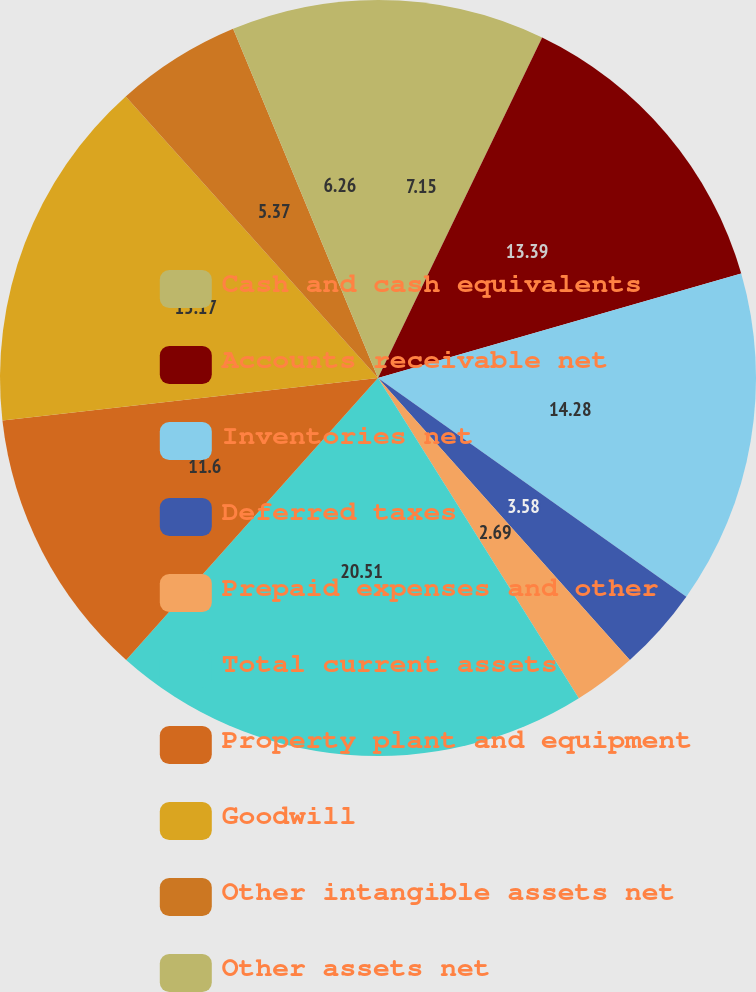<chart> <loc_0><loc_0><loc_500><loc_500><pie_chart><fcel>Cash and cash equivalents<fcel>Accounts receivable net<fcel>Inventories net<fcel>Deferred taxes<fcel>Prepaid expenses and other<fcel>Total current assets<fcel>Property plant and equipment<fcel>Goodwill<fcel>Other intangible assets net<fcel>Other assets net<nl><fcel>7.15%<fcel>13.39%<fcel>14.28%<fcel>3.58%<fcel>2.69%<fcel>20.52%<fcel>11.6%<fcel>15.17%<fcel>5.37%<fcel>6.26%<nl></chart> 